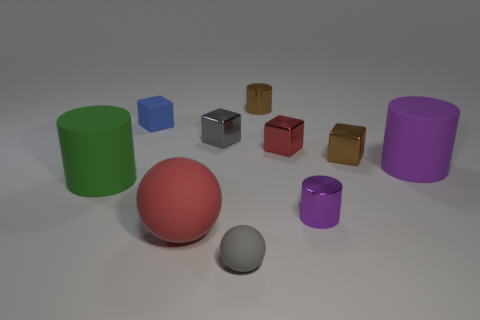Subtract all cylinders. How many objects are left? 6 Add 2 small purple metal things. How many small purple metal things exist? 3 Subtract all red spheres. How many spheres are left? 1 Subtract all small brown cylinders. How many cylinders are left? 3 Subtract 0 blue cylinders. How many objects are left? 10 Subtract 4 blocks. How many blocks are left? 0 Subtract all gray cubes. Subtract all purple spheres. How many cubes are left? 3 Subtract all blue spheres. How many gray cylinders are left? 0 Subtract all tiny red metal cubes. Subtract all cyan objects. How many objects are left? 9 Add 4 tiny metal cylinders. How many tiny metal cylinders are left? 6 